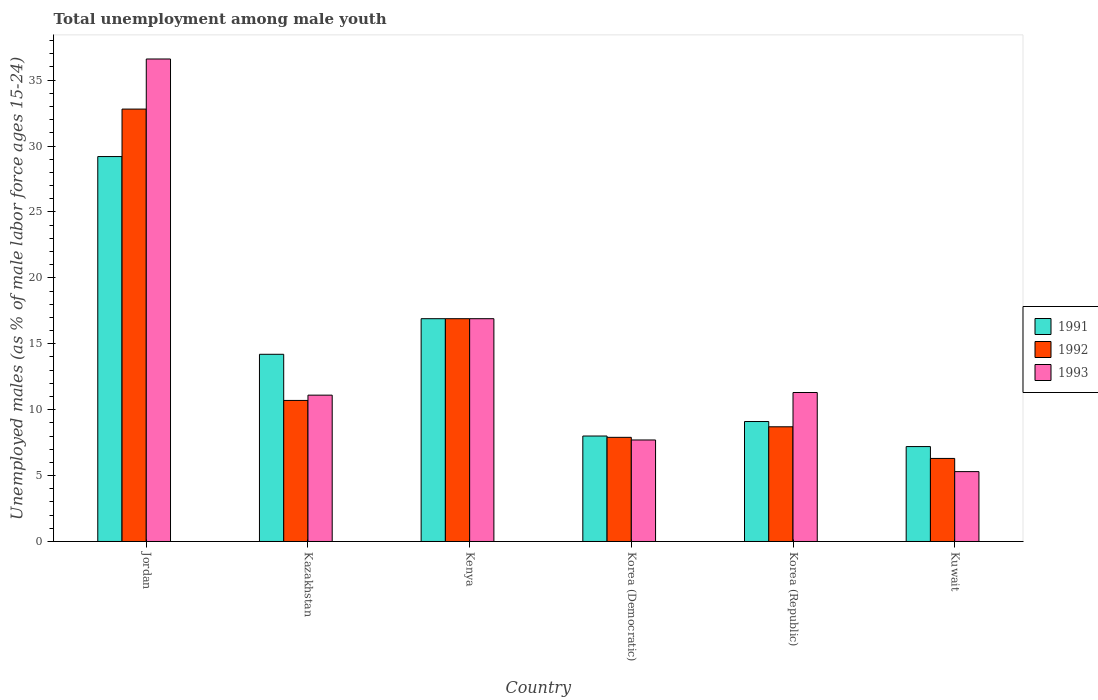How many different coloured bars are there?
Your answer should be very brief. 3. How many groups of bars are there?
Give a very brief answer. 6. Are the number of bars on each tick of the X-axis equal?
Ensure brevity in your answer.  Yes. How many bars are there on the 1st tick from the right?
Offer a very short reply. 3. What is the label of the 5th group of bars from the left?
Provide a short and direct response. Korea (Republic). What is the percentage of unemployed males in in 1992 in Kuwait?
Make the answer very short. 6.3. Across all countries, what is the maximum percentage of unemployed males in in 1991?
Make the answer very short. 29.2. Across all countries, what is the minimum percentage of unemployed males in in 1993?
Ensure brevity in your answer.  5.3. In which country was the percentage of unemployed males in in 1991 maximum?
Give a very brief answer. Jordan. In which country was the percentage of unemployed males in in 1991 minimum?
Your response must be concise. Kuwait. What is the total percentage of unemployed males in in 1991 in the graph?
Give a very brief answer. 84.6. What is the difference between the percentage of unemployed males in in 1991 in Kenya and that in Kuwait?
Provide a short and direct response. 9.7. What is the difference between the percentage of unemployed males in in 1993 in Korea (Democratic) and the percentage of unemployed males in in 1991 in Jordan?
Give a very brief answer. -21.5. What is the average percentage of unemployed males in in 1991 per country?
Your response must be concise. 14.1. What is the difference between the percentage of unemployed males in of/in 1993 and percentage of unemployed males in of/in 1992 in Korea (Republic)?
Offer a very short reply. 2.6. What is the ratio of the percentage of unemployed males in in 1992 in Jordan to that in Kuwait?
Your response must be concise. 5.21. What is the difference between the highest and the second highest percentage of unemployed males in in 1992?
Offer a terse response. 15.9. What is the difference between the highest and the lowest percentage of unemployed males in in 1993?
Give a very brief answer. 31.3. In how many countries, is the percentage of unemployed males in in 1992 greater than the average percentage of unemployed males in in 1992 taken over all countries?
Keep it short and to the point. 2. Is the sum of the percentage of unemployed males in in 1991 in Kenya and Kuwait greater than the maximum percentage of unemployed males in in 1993 across all countries?
Offer a terse response. No. What does the 3rd bar from the left in Jordan represents?
Ensure brevity in your answer.  1993. What does the 3rd bar from the right in Korea (Democratic) represents?
Your answer should be very brief. 1991. Is it the case that in every country, the sum of the percentage of unemployed males in in 1991 and percentage of unemployed males in in 1992 is greater than the percentage of unemployed males in in 1993?
Provide a succinct answer. Yes. How many bars are there?
Give a very brief answer. 18. Are all the bars in the graph horizontal?
Make the answer very short. No. How many countries are there in the graph?
Offer a very short reply. 6. What is the difference between two consecutive major ticks on the Y-axis?
Give a very brief answer. 5. Does the graph contain grids?
Provide a succinct answer. No. Where does the legend appear in the graph?
Give a very brief answer. Center right. How many legend labels are there?
Provide a succinct answer. 3. What is the title of the graph?
Your answer should be very brief. Total unemployment among male youth. Does "1972" appear as one of the legend labels in the graph?
Ensure brevity in your answer.  No. What is the label or title of the Y-axis?
Your response must be concise. Unemployed males (as % of male labor force ages 15-24). What is the Unemployed males (as % of male labor force ages 15-24) in 1991 in Jordan?
Your response must be concise. 29.2. What is the Unemployed males (as % of male labor force ages 15-24) of 1992 in Jordan?
Give a very brief answer. 32.8. What is the Unemployed males (as % of male labor force ages 15-24) of 1993 in Jordan?
Your answer should be compact. 36.6. What is the Unemployed males (as % of male labor force ages 15-24) in 1991 in Kazakhstan?
Provide a succinct answer. 14.2. What is the Unemployed males (as % of male labor force ages 15-24) of 1992 in Kazakhstan?
Offer a very short reply. 10.7. What is the Unemployed males (as % of male labor force ages 15-24) of 1993 in Kazakhstan?
Your answer should be very brief. 11.1. What is the Unemployed males (as % of male labor force ages 15-24) in 1991 in Kenya?
Your answer should be very brief. 16.9. What is the Unemployed males (as % of male labor force ages 15-24) in 1992 in Kenya?
Make the answer very short. 16.9. What is the Unemployed males (as % of male labor force ages 15-24) in 1993 in Kenya?
Your answer should be very brief. 16.9. What is the Unemployed males (as % of male labor force ages 15-24) in 1992 in Korea (Democratic)?
Provide a succinct answer. 7.9. What is the Unemployed males (as % of male labor force ages 15-24) in 1993 in Korea (Democratic)?
Make the answer very short. 7.7. What is the Unemployed males (as % of male labor force ages 15-24) of 1991 in Korea (Republic)?
Offer a very short reply. 9.1. What is the Unemployed males (as % of male labor force ages 15-24) in 1992 in Korea (Republic)?
Ensure brevity in your answer.  8.7. What is the Unemployed males (as % of male labor force ages 15-24) in 1993 in Korea (Republic)?
Offer a terse response. 11.3. What is the Unemployed males (as % of male labor force ages 15-24) in 1991 in Kuwait?
Give a very brief answer. 7.2. What is the Unemployed males (as % of male labor force ages 15-24) of 1992 in Kuwait?
Offer a terse response. 6.3. What is the Unemployed males (as % of male labor force ages 15-24) of 1993 in Kuwait?
Offer a terse response. 5.3. Across all countries, what is the maximum Unemployed males (as % of male labor force ages 15-24) of 1991?
Provide a short and direct response. 29.2. Across all countries, what is the maximum Unemployed males (as % of male labor force ages 15-24) in 1992?
Your answer should be very brief. 32.8. Across all countries, what is the maximum Unemployed males (as % of male labor force ages 15-24) of 1993?
Keep it short and to the point. 36.6. Across all countries, what is the minimum Unemployed males (as % of male labor force ages 15-24) in 1991?
Ensure brevity in your answer.  7.2. Across all countries, what is the minimum Unemployed males (as % of male labor force ages 15-24) of 1992?
Provide a short and direct response. 6.3. Across all countries, what is the minimum Unemployed males (as % of male labor force ages 15-24) of 1993?
Ensure brevity in your answer.  5.3. What is the total Unemployed males (as % of male labor force ages 15-24) in 1991 in the graph?
Ensure brevity in your answer.  84.6. What is the total Unemployed males (as % of male labor force ages 15-24) of 1992 in the graph?
Ensure brevity in your answer.  83.3. What is the total Unemployed males (as % of male labor force ages 15-24) of 1993 in the graph?
Give a very brief answer. 88.9. What is the difference between the Unemployed males (as % of male labor force ages 15-24) of 1991 in Jordan and that in Kazakhstan?
Offer a terse response. 15. What is the difference between the Unemployed males (as % of male labor force ages 15-24) of 1992 in Jordan and that in Kazakhstan?
Your response must be concise. 22.1. What is the difference between the Unemployed males (as % of male labor force ages 15-24) of 1993 in Jordan and that in Kazakhstan?
Your response must be concise. 25.5. What is the difference between the Unemployed males (as % of male labor force ages 15-24) of 1991 in Jordan and that in Kenya?
Make the answer very short. 12.3. What is the difference between the Unemployed males (as % of male labor force ages 15-24) of 1993 in Jordan and that in Kenya?
Provide a short and direct response. 19.7. What is the difference between the Unemployed males (as % of male labor force ages 15-24) of 1991 in Jordan and that in Korea (Democratic)?
Offer a terse response. 21.2. What is the difference between the Unemployed males (as % of male labor force ages 15-24) in 1992 in Jordan and that in Korea (Democratic)?
Make the answer very short. 24.9. What is the difference between the Unemployed males (as % of male labor force ages 15-24) of 1993 in Jordan and that in Korea (Democratic)?
Your response must be concise. 28.9. What is the difference between the Unemployed males (as % of male labor force ages 15-24) in 1991 in Jordan and that in Korea (Republic)?
Your answer should be compact. 20.1. What is the difference between the Unemployed males (as % of male labor force ages 15-24) of 1992 in Jordan and that in Korea (Republic)?
Give a very brief answer. 24.1. What is the difference between the Unemployed males (as % of male labor force ages 15-24) of 1993 in Jordan and that in Korea (Republic)?
Your response must be concise. 25.3. What is the difference between the Unemployed males (as % of male labor force ages 15-24) in 1991 in Jordan and that in Kuwait?
Offer a very short reply. 22. What is the difference between the Unemployed males (as % of male labor force ages 15-24) of 1992 in Jordan and that in Kuwait?
Keep it short and to the point. 26.5. What is the difference between the Unemployed males (as % of male labor force ages 15-24) in 1993 in Jordan and that in Kuwait?
Your answer should be very brief. 31.3. What is the difference between the Unemployed males (as % of male labor force ages 15-24) of 1993 in Kazakhstan and that in Kenya?
Offer a very short reply. -5.8. What is the difference between the Unemployed males (as % of male labor force ages 15-24) of 1991 in Kazakhstan and that in Korea (Republic)?
Keep it short and to the point. 5.1. What is the difference between the Unemployed males (as % of male labor force ages 15-24) of 1992 in Kazakhstan and that in Korea (Republic)?
Give a very brief answer. 2. What is the difference between the Unemployed males (as % of male labor force ages 15-24) in 1992 in Kazakhstan and that in Kuwait?
Provide a short and direct response. 4.4. What is the difference between the Unemployed males (as % of male labor force ages 15-24) of 1991 in Kenya and that in Korea (Democratic)?
Offer a very short reply. 8.9. What is the difference between the Unemployed males (as % of male labor force ages 15-24) of 1993 in Kenya and that in Korea (Democratic)?
Your response must be concise. 9.2. What is the difference between the Unemployed males (as % of male labor force ages 15-24) of 1991 in Kenya and that in Korea (Republic)?
Make the answer very short. 7.8. What is the difference between the Unemployed males (as % of male labor force ages 15-24) in 1993 in Kenya and that in Korea (Republic)?
Make the answer very short. 5.6. What is the difference between the Unemployed males (as % of male labor force ages 15-24) of 1992 in Korea (Democratic) and that in Korea (Republic)?
Ensure brevity in your answer.  -0.8. What is the difference between the Unemployed males (as % of male labor force ages 15-24) of 1993 in Korea (Democratic) and that in Kuwait?
Provide a succinct answer. 2.4. What is the difference between the Unemployed males (as % of male labor force ages 15-24) of 1992 in Korea (Republic) and that in Kuwait?
Give a very brief answer. 2.4. What is the difference between the Unemployed males (as % of male labor force ages 15-24) of 1993 in Korea (Republic) and that in Kuwait?
Provide a short and direct response. 6. What is the difference between the Unemployed males (as % of male labor force ages 15-24) of 1991 in Jordan and the Unemployed males (as % of male labor force ages 15-24) of 1992 in Kazakhstan?
Keep it short and to the point. 18.5. What is the difference between the Unemployed males (as % of male labor force ages 15-24) in 1992 in Jordan and the Unemployed males (as % of male labor force ages 15-24) in 1993 in Kazakhstan?
Offer a very short reply. 21.7. What is the difference between the Unemployed males (as % of male labor force ages 15-24) of 1991 in Jordan and the Unemployed males (as % of male labor force ages 15-24) of 1993 in Kenya?
Your answer should be compact. 12.3. What is the difference between the Unemployed males (as % of male labor force ages 15-24) in 1991 in Jordan and the Unemployed males (as % of male labor force ages 15-24) in 1992 in Korea (Democratic)?
Provide a short and direct response. 21.3. What is the difference between the Unemployed males (as % of male labor force ages 15-24) of 1992 in Jordan and the Unemployed males (as % of male labor force ages 15-24) of 1993 in Korea (Democratic)?
Offer a very short reply. 25.1. What is the difference between the Unemployed males (as % of male labor force ages 15-24) in 1991 in Jordan and the Unemployed males (as % of male labor force ages 15-24) in 1992 in Korea (Republic)?
Provide a short and direct response. 20.5. What is the difference between the Unemployed males (as % of male labor force ages 15-24) of 1991 in Jordan and the Unemployed males (as % of male labor force ages 15-24) of 1993 in Korea (Republic)?
Keep it short and to the point. 17.9. What is the difference between the Unemployed males (as % of male labor force ages 15-24) of 1991 in Jordan and the Unemployed males (as % of male labor force ages 15-24) of 1992 in Kuwait?
Ensure brevity in your answer.  22.9. What is the difference between the Unemployed males (as % of male labor force ages 15-24) of 1991 in Jordan and the Unemployed males (as % of male labor force ages 15-24) of 1993 in Kuwait?
Keep it short and to the point. 23.9. What is the difference between the Unemployed males (as % of male labor force ages 15-24) of 1992 in Jordan and the Unemployed males (as % of male labor force ages 15-24) of 1993 in Kuwait?
Your answer should be compact. 27.5. What is the difference between the Unemployed males (as % of male labor force ages 15-24) in 1991 in Kazakhstan and the Unemployed males (as % of male labor force ages 15-24) in 1992 in Kenya?
Keep it short and to the point. -2.7. What is the difference between the Unemployed males (as % of male labor force ages 15-24) of 1991 in Kazakhstan and the Unemployed males (as % of male labor force ages 15-24) of 1993 in Kenya?
Give a very brief answer. -2.7. What is the difference between the Unemployed males (as % of male labor force ages 15-24) in 1991 in Kazakhstan and the Unemployed males (as % of male labor force ages 15-24) in 1993 in Korea (Democratic)?
Provide a succinct answer. 6.5. What is the difference between the Unemployed males (as % of male labor force ages 15-24) of 1991 in Kazakhstan and the Unemployed males (as % of male labor force ages 15-24) of 1992 in Korea (Republic)?
Offer a terse response. 5.5. What is the difference between the Unemployed males (as % of male labor force ages 15-24) in 1991 in Kazakhstan and the Unemployed males (as % of male labor force ages 15-24) in 1993 in Korea (Republic)?
Keep it short and to the point. 2.9. What is the difference between the Unemployed males (as % of male labor force ages 15-24) of 1992 in Kazakhstan and the Unemployed males (as % of male labor force ages 15-24) of 1993 in Korea (Republic)?
Keep it short and to the point. -0.6. What is the difference between the Unemployed males (as % of male labor force ages 15-24) of 1992 in Kazakhstan and the Unemployed males (as % of male labor force ages 15-24) of 1993 in Kuwait?
Keep it short and to the point. 5.4. What is the difference between the Unemployed males (as % of male labor force ages 15-24) of 1991 in Kenya and the Unemployed males (as % of male labor force ages 15-24) of 1992 in Korea (Democratic)?
Offer a terse response. 9. What is the difference between the Unemployed males (as % of male labor force ages 15-24) of 1991 in Kenya and the Unemployed males (as % of male labor force ages 15-24) of 1992 in Kuwait?
Offer a very short reply. 10.6. What is the difference between the Unemployed males (as % of male labor force ages 15-24) of 1992 in Kenya and the Unemployed males (as % of male labor force ages 15-24) of 1993 in Kuwait?
Keep it short and to the point. 11.6. What is the difference between the Unemployed males (as % of male labor force ages 15-24) of 1991 in Korea (Democratic) and the Unemployed males (as % of male labor force ages 15-24) of 1992 in Korea (Republic)?
Ensure brevity in your answer.  -0.7. What is the difference between the Unemployed males (as % of male labor force ages 15-24) of 1991 in Korea (Democratic) and the Unemployed males (as % of male labor force ages 15-24) of 1993 in Korea (Republic)?
Your response must be concise. -3.3. What is the difference between the Unemployed males (as % of male labor force ages 15-24) of 1991 in Korea (Democratic) and the Unemployed males (as % of male labor force ages 15-24) of 1992 in Kuwait?
Ensure brevity in your answer.  1.7. What is the difference between the Unemployed males (as % of male labor force ages 15-24) in 1991 in Korea (Democratic) and the Unemployed males (as % of male labor force ages 15-24) in 1993 in Kuwait?
Your response must be concise. 2.7. What is the difference between the Unemployed males (as % of male labor force ages 15-24) of 1991 in Korea (Republic) and the Unemployed males (as % of male labor force ages 15-24) of 1993 in Kuwait?
Make the answer very short. 3.8. What is the difference between the Unemployed males (as % of male labor force ages 15-24) of 1992 in Korea (Republic) and the Unemployed males (as % of male labor force ages 15-24) of 1993 in Kuwait?
Your response must be concise. 3.4. What is the average Unemployed males (as % of male labor force ages 15-24) in 1992 per country?
Keep it short and to the point. 13.88. What is the average Unemployed males (as % of male labor force ages 15-24) in 1993 per country?
Offer a very short reply. 14.82. What is the difference between the Unemployed males (as % of male labor force ages 15-24) of 1991 and Unemployed males (as % of male labor force ages 15-24) of 1993 in Jordan?
Your answer should be very brief. -7.4. What is the difference between the Unemployed males (as % of male labor force ages 15-24) of 1992 and Unemployed males (as % of male labor force ages 15-24) of 1993 in Jordan?
Your answer should be compact. -3.8. What is the difference between the Unemployed males (as % of male labor force ages 15-24) in 1992 and Unemployed males (as % of male labor force ages 15-24) in 1993 in Kazakhstan?
Your response must be concise. -0.4. What is the difference between the Unemployed males (as % of male labor force ages 15-24) of 1991 and Unemployed males (as % of male labor force ages 15-24) of 1992 in Kenya?
Give a very brief answer. 0. What is the difference between the Unemployed males (as % of male labor force ages 15-24) of 1991 and Unemployed males (as % of male labor force ages 15-24) of 1993 in Korea (Democratic)?
Your answer should be very brief. 0.3. What is the difference between the Unemployed males (as % of male labor force ages 15-24) in 1992 and Unemployed males (as % of male labor force ages 15-24) in 1993 in Korea (Democratic)?
Your answer should be compact. 0.2. What is the difference between the Unemployed males (as % of male labor force ages 15-24) of 1992 and Unemployed males (as % of male labor force ages 15-24) of 1993 in Korea (Republic)?
Ensure brevity in your answer.  -2.6. What is the difference between the Unemployed males (as % of male labor force ages 15-24) of 1991 and Unemployed males (as % of male labor force ages 15-24) of 1993 in Kuwait?
Provide a short and direct response. 1.9. What is the ratio of the Unemployed males (as % of male labor force ages 15-24) in 1991 in Jordan to that in Kazakhstan?
Ensure brevity in your answer.  2.06. What is the ratio of the Unemployed males (as % of male labor force ages 15-24) in 1992 in Jordan to that in Kazakhstan?
Provide a succinct answer. 3.07. What is the ratio of the Unemployed males (as % of male labor force ages 15-24) in 1993 in Jordan to that in Kazakhstan?
Your response must be concise. 3.3. What is the ratio of the Unemployed males (as % of male labor force ages 15-24) of 1991 in Jordan to that in Kenya?
Provide a succinct answer. 1.73. What is the ratio of the Unemployed males (as % of male labor force ages 15-24) in 1992 in Jordan to that in Kenya?
Offer a very short reply. 1.94. What is the ratio of the Unemployed males (as % of male labor force ages 15-24) of 1993 in Jordan to that in Kenya?
Ensure brevity in your answer.  2.17. What is the ratio of the Unemployed males (as % of male labor force ages 15-24) in 1991 in Jordan to that in Korea (Democratic)?
Keep it short and to the point. 3.65. What is the ratio of the Unemployed males (as % of male labor force ages 15-24) of 1992 in Jordan to that in Korea (Democratic)?
Provide a short and direct response. 4.15. What is the ratio of the Unemployed males (as % of male labor force ages 15-24) of 1993 in Jordan to that in Korea (Democratic)?
Ensure brevity in your answer.  4.75. What is the ratio of the Unemployed males (as % of male labor force ages 15-24) in 1991 in Jordan to that in Korea (Republic)?
Provide a short and direct response. 3.21. What is the ratio of the Unemployed males (as % of male labor force ages 15-24) of 1992 in Jordan to that in Korea (Republic)?
Give a very brief answer. 3.77. What is the ratio of the Unemployed males (as % of male labor force ages 15-24) of 1993 in Jordan to that in Korea (Republic)?
Provide a succinct answer. 3.24. What is the ratio of the Unemployed males (as % of male labor force ages 15-24) of 1991 in Jordan to that in Kuwait?
Offer a terse response. 4.06. What is the ratio of the Unemployed males (as % of male labor force ages 15-24) in 1992 in Jordan to that in Kuwait?
Ensure brevity in your answer.  5.21. What is the ratio of the Unemployed males (as % of male labor force ages 15-24) in 1993 in Jordan to that in Kuwait?
Your answer should be compact. 6.91. What is the ratio of the Unemployed males (as % of male labor force ages 15-24) in 1991 in Kazakhstan to that in Kenya?
Your answer should be compact. 0.84. What is the ratio of the Unemployed males (as % of male labor force ages 15-24) in 1992 in Kazakhstan to that in Kenya?
Give a very brief answer. 0.63. What is the ratio of the Unemployed males (as % of male labor force ages 15-24) in 1993 in Kazakhstan to that in Kenya?
Your response must be concise. 0.66. What is the ratio of the Unemployed males (as % of male labor force ages 15-24) in 1991 in Kazakhstan to that in Korea (Democratic)?
Your response must be concise. 1.77. What is the ratio of the Unemployed males (as % of male labor force ages 15-24) of 1992 in Kazakhstan to that in Korea (Democratic)?
Give a very brief answer. 1.35. What is the ratio of the Unemployed males (as % of male labor force ages 15-24) of 1993 in Kazakhstan to that in Korea (Democratic)?
Provide a short and direct response. 1.44. What is the ratio of the Unemployed males (as % of male labor force ages 15-24) of 1991 in Kazakhstan to that in Korea (Republic)?
Offer a terse response. 1.56. What is the ratio of the Unemployed males (as % of male labor force ages 15-24) of 1992 in Kazakhstan to that in Korea (Republic)?
Give a very brief answer. 1.23. What is the ratio of the Unemployed males (as % of male labor force ages 15-24) of 1993 in Kazakhstan to that in Korea (Republic)?
Make the answer very short. 0.98. What is the ratio of the Unemployed males (as % of male labor force ages 15-24) in 1991 in Kazakhstan to that in Kuwait?
Offer a very short reply. 1.97. What is the ratio of the Unemployed males (as % of male labor force ages 15-24) of 1992 in Kazakhstan to that in Kuwait?
Give a very brief answer. 1.7. What is the ratio of the Unemployed males (as % of male labor force ages 15-24) in 1993 in Kazakhstan to that in Kuwait?
Make the answer very short. 2.09. What is the ratio of the Unemployed males (as % of male labor force ages 15-24) in 1991 in Kenya to that in Korea (Democratic)?
Your response must be concise. 2.11. What is the ratio of the Unemployed males (as % of male labor force ages 15-24) in 1992 in Kenya to that in Korea (Democratic)?
Your answer should be very brief. 2.14. What is the ratio of the Unemployed males (as % of male labor force ages 15-24) in 1993 in Kenya to that in Korea (Democratic)?
Ensure brevity in your answer.  2.19. What is the ratio of the Unemployed males (as % of male labor force ages 15-24) in 1991 in Kenya to that in Korea (Republic)?
Make the answer very short. 1.86. What is the ratio of the Unemployed males (as % of male labor force ages 15-24) of 1992 in Kenya to that in Korea (Republic)?
Your answer should be compact. 1.94. What is the ratio of the Unemployed males (as % of male labor force ages 15-24) of 1993 in Kenya to that in Korea (Republic)?
Offer a terse response. 1.5. What is the ratio of the Unemployed males (as % of male labor force ages 15-24) of 1991 in Kenya to that in Kuwait?
Your response must be concise. 2.35. What is the ratio of the Unemployed males (as % of male labor force ages 15-24) in 1992 in Kenya to that in Kuwait?
Keep it short and to the point. 2.68. What is the ratio of the Unemployed males (as % of male labor force ages 15-24) of 1993 in Kenya to that in Kuwait?
Provide a short and direct response. 3.19. What is the ratio of the Unemployed males (as % of male labor force ages 15-24) in 1991 in Korea (Democratic) to that in Korea (Republic)?
Make the answer very short. 0.88. What is the ratio of the Unemployed males (as % of male labor force ages 15-24) in 1992 in Korea (Democratic) to that in Korea (Republic)?
Provide a short and direct response. 0.91. What is the ratio of the Unemployed males (as % of male labor force ages 15-24) in 1993 in Korea (Democratic) to that in Korea (Republic)?
Provide a succinct answer. 0.68. What is the ratio of the Unemployed males (as % of male labor force ages 15-24) in 1992 in Korea (Democratic) to that in Kuwait?
Ensure brevity in your answer.  1.25. What is the ratio of the Unemployed males (as % of male labor force ages 15-24) of 1993 in Korea (Democratic) to that in Kuwait?
Give a very brief answer. 1.45. What is the ratio of the Unemployed males (as % of male labor force ages 15-24) of 1991 in Korea (Republic) to that in Kuwait?
Offer a terse response. 1.26. What is the ratio of the Unemployed males (as % of male labor force ages 15-24) in 1992 in Korea (Republic) to that in Kuwait?
Your response must be concise. 1.38. What is the ratio of the Unemployed males (as % of male labor force ages 15-24) of 1993 in Korea (Republic) to that in Kuwait?
Ensure brevity in your answer.  2.13. What is the difference between the highest and the second highest Unemployed males (as % of male labor force ages 15-24) in 1993?
Ensure brevity in your answer.  19.7. What is the difference between the highest and the lowest Unemployed males (as % of male labor force ages 15-24) of 1991?
Your answer should be very brief. 22. What is the difference between the highest and the lowest Unemployed males (as % of male labor force ages 15-24) in 1992?
Make the answer very short. 26.5. What is the difference between the highest and the lowest Unemployed males (as % of male labor force ages 15-24) in 1993?
Offer a terse response. 31.3. 